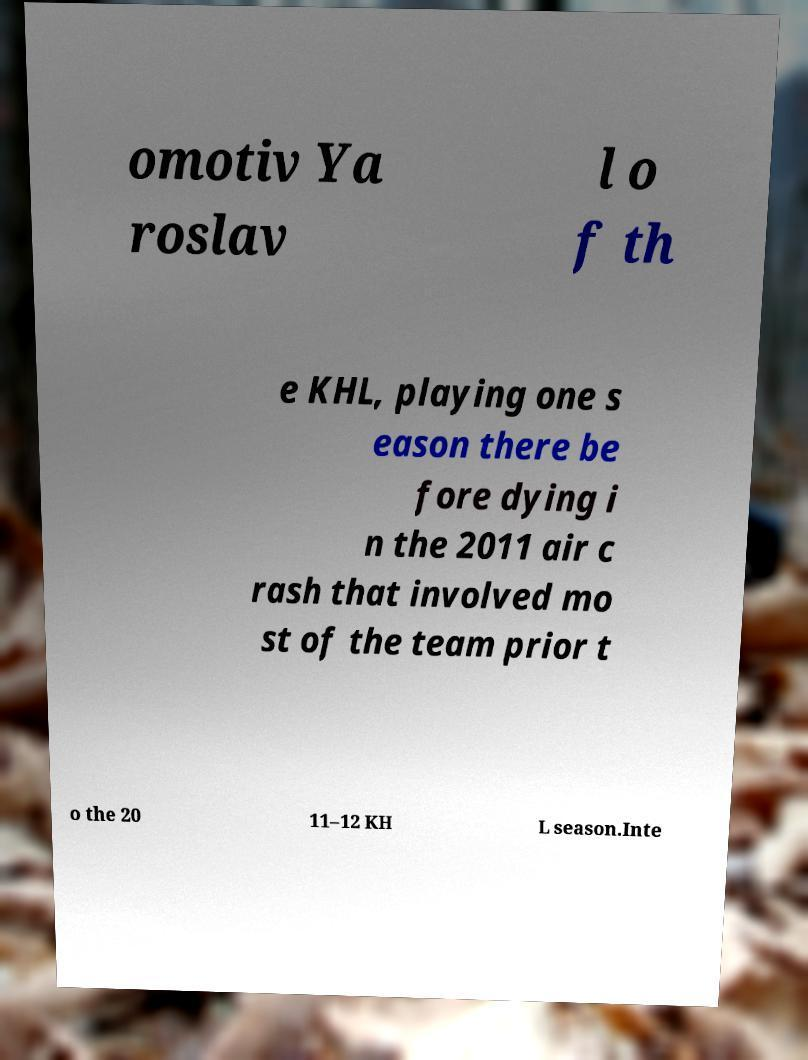I need the written content from this picture converted into text. Can you do that? omotiv Ya roslav l o f th e KHL, playing one s eason there be fore dying i n the 2011 air c rash that involved mo st of the team prior t o the 20 11–12 KH L season.Inte 